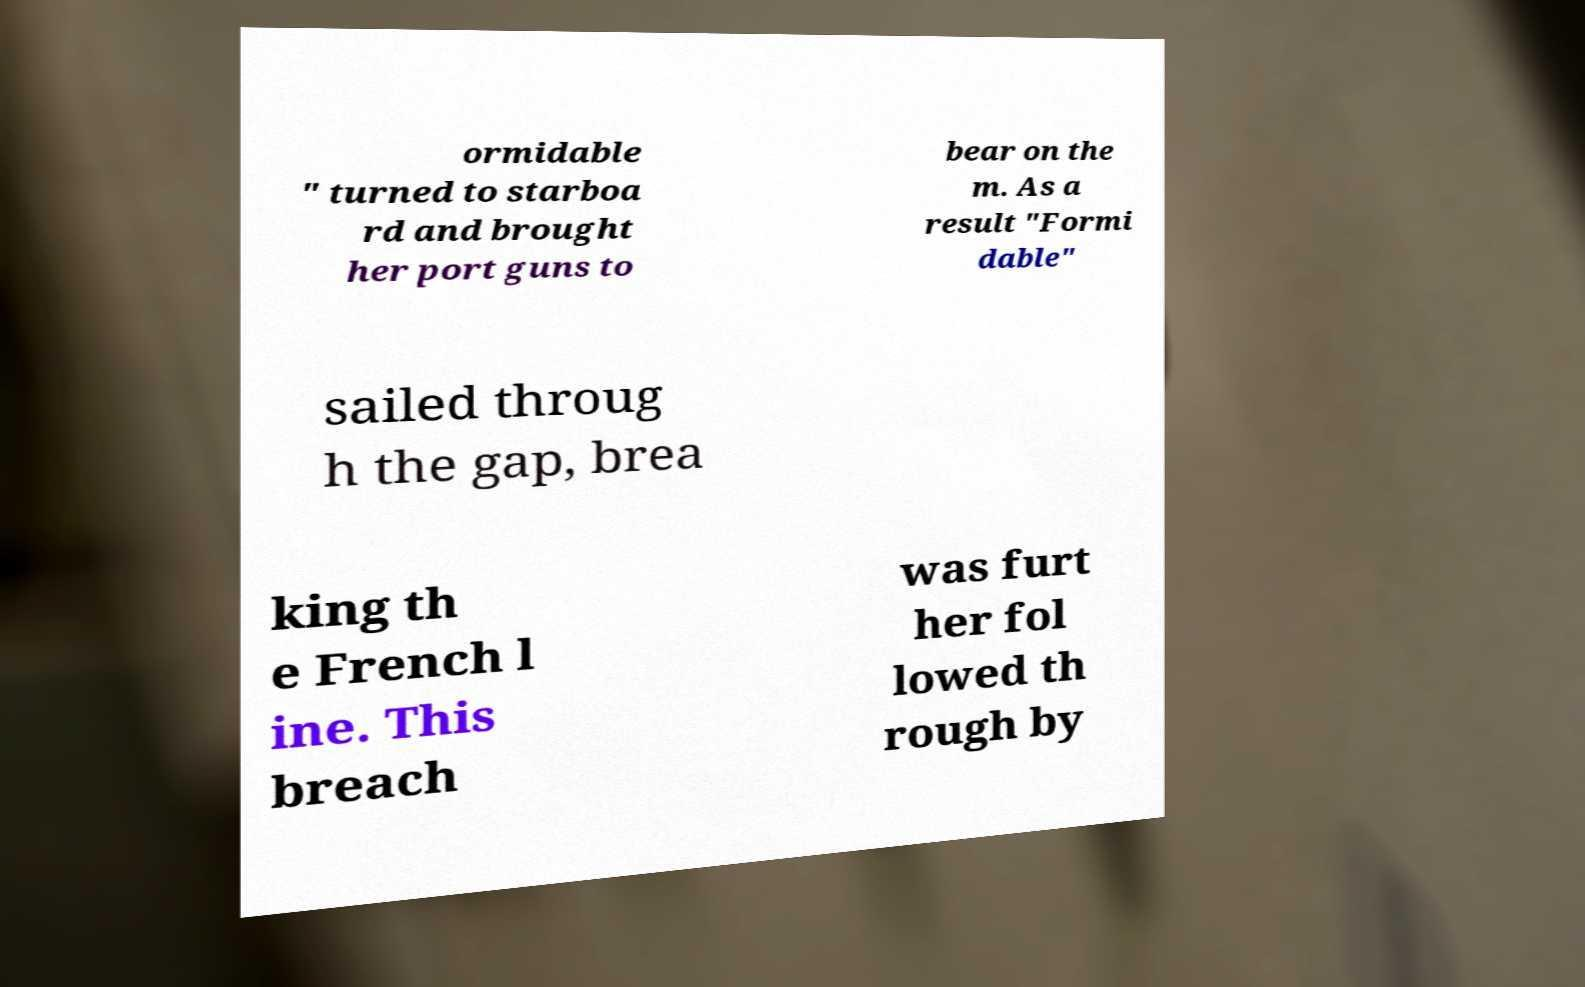Please read and relay the text visible in this image. What does it say? ormidable " turned to starboa rd and brought her port guns to bear on the m. As a result "Formi dable" sailed throug h the gap, brea king th e French l ine. This breach was furt her fol lowed th rough by 